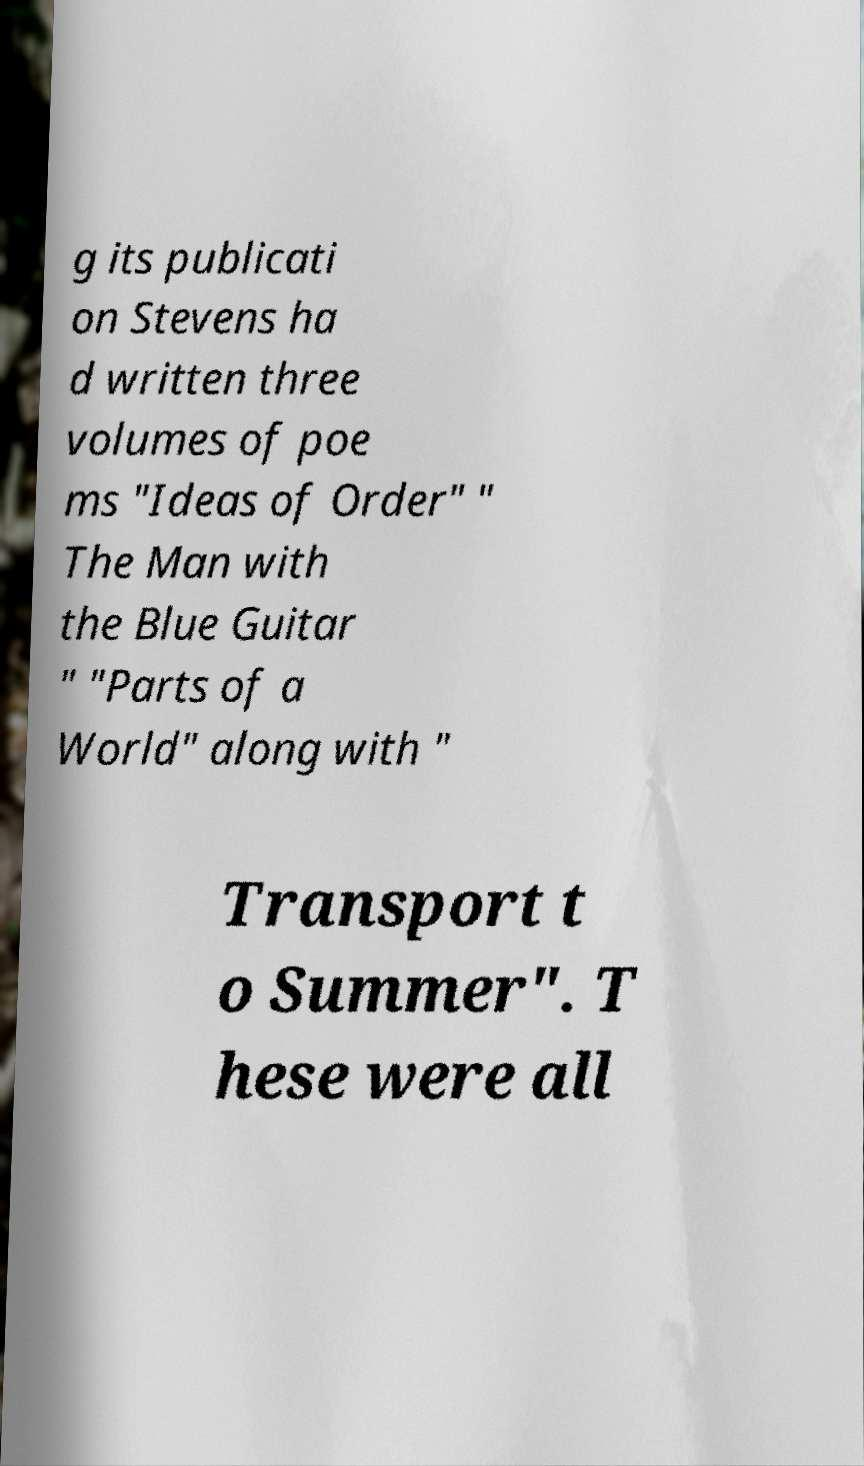Could you extract and type out the text from this image? g its publicati on Stevens ha d written three volumes of poe ms "Ideas of Order" " The Man with the Blue Guitar " "Parts of a World" along with " Transport t o Summer". T hese were all 